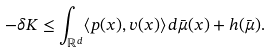Convert formula to latex. <formula><loc_0><loc_0><loc_500><loc_500>- \delta K \leq \int _ { \mathbb { R } ^ { d } } \langle p ( x ) , v ( x ) \rangle \, d \bar { \mu } ( x ) + h ( \bar { \mu } ) .</formula> 